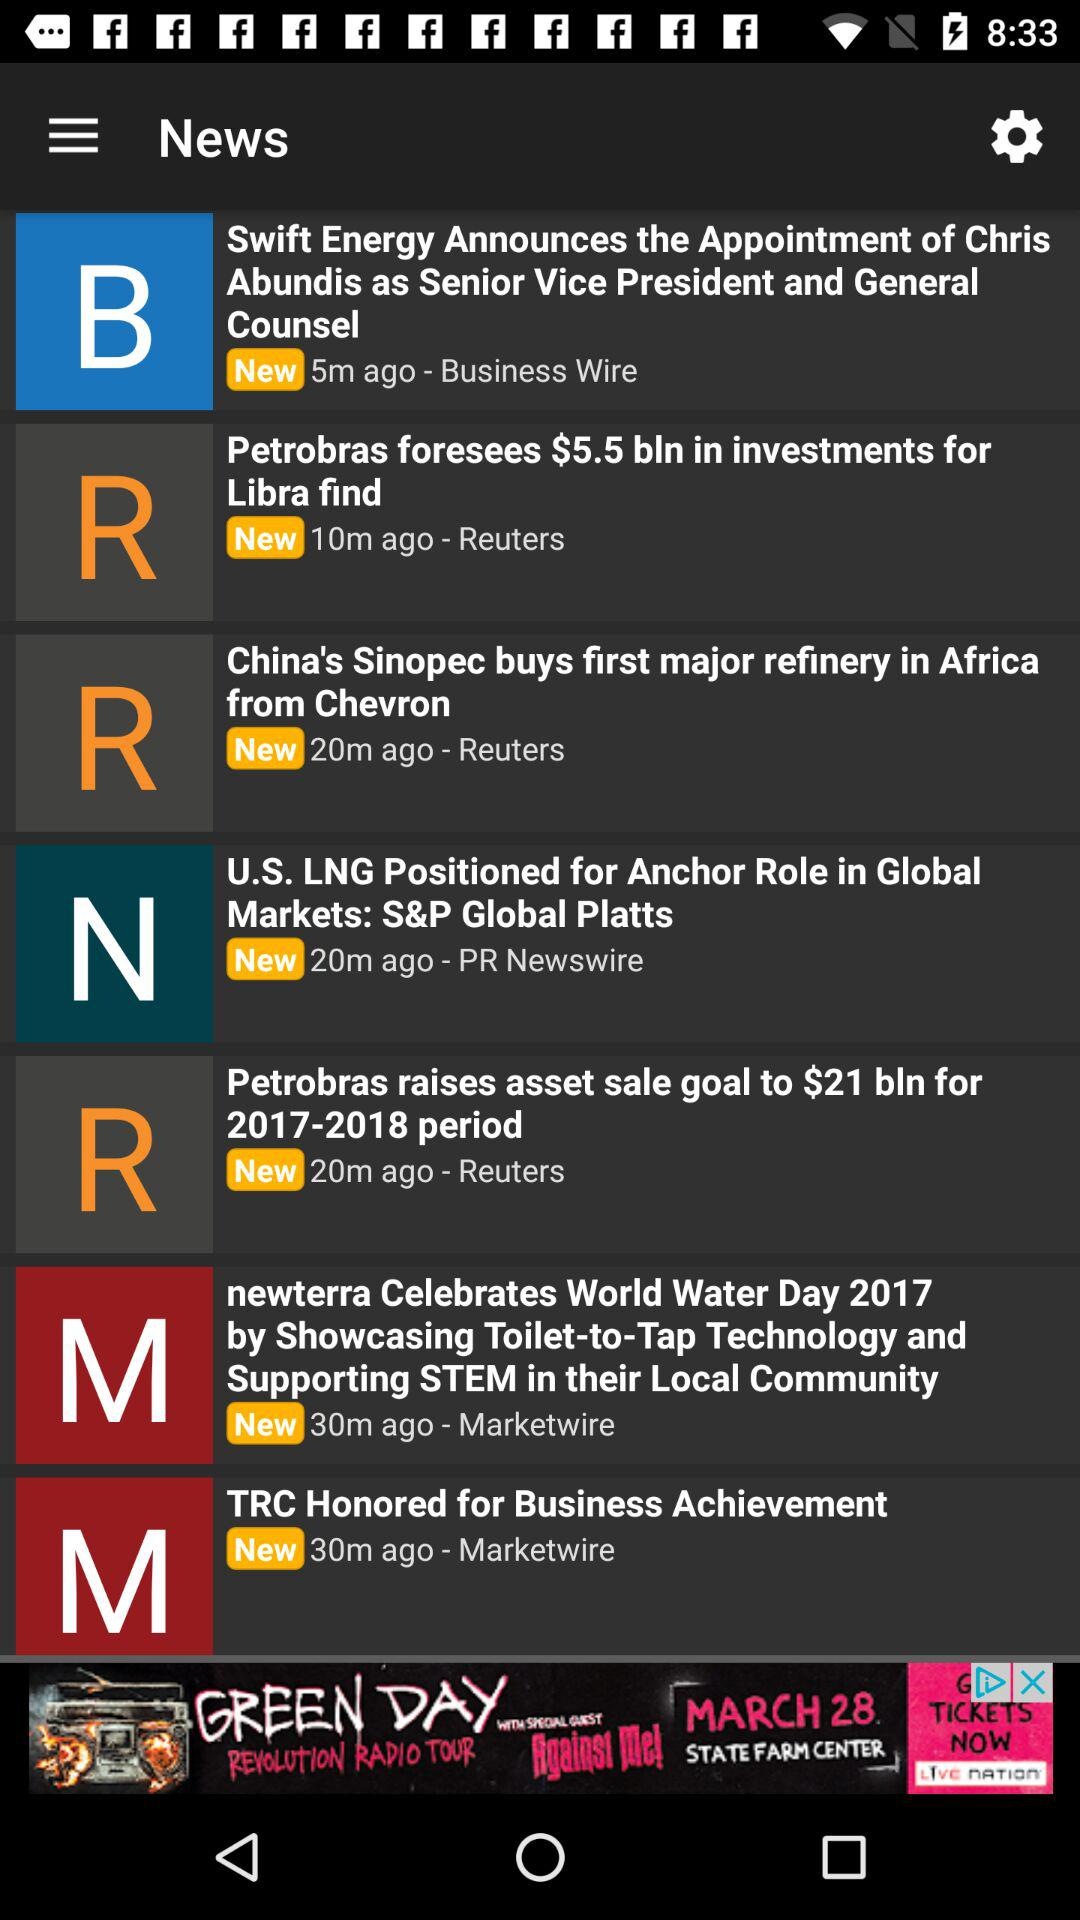Which news was broadcast 5 minutes ago? The news "Swift Energy Announces the Appointment of Chris Abundis as Senior Vice President and General Counsel" was broadcast 5 minutes ago. 